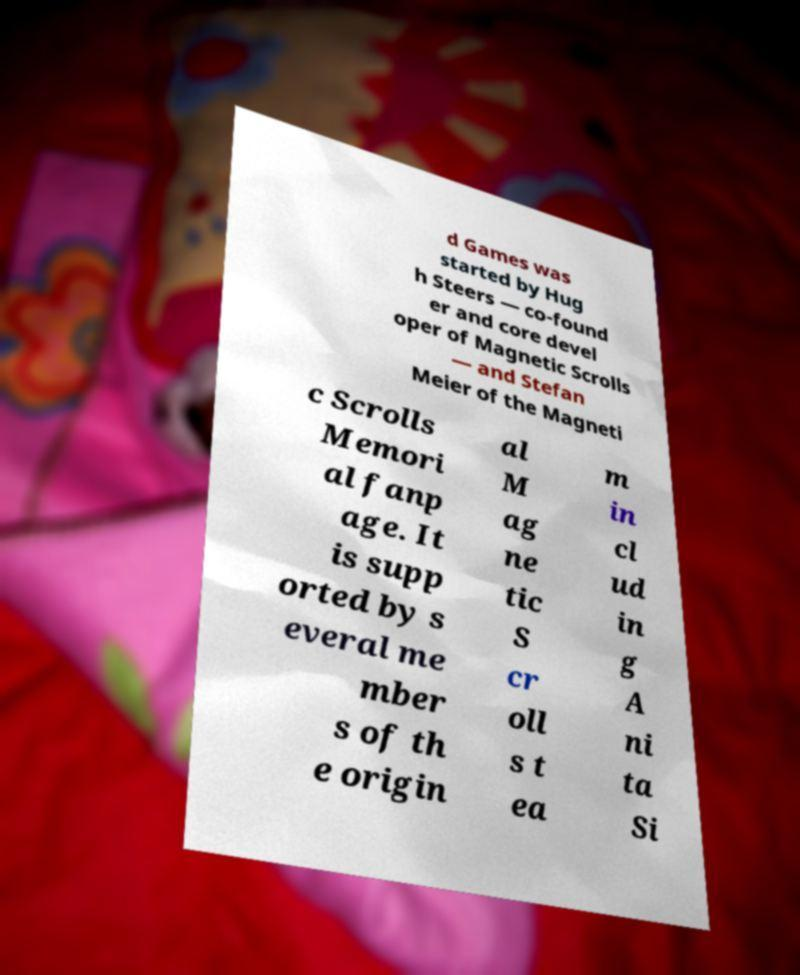For documentation purposes, I need the text within this image transcribed. Could you provide that? d Games was started by Hug h Steers — co-found er and core devel oper of Magnetic Scrolls — and Stefan Meier of the Magneti c Scrolls Memori al fanp age. It is supp orted by s everal me mber s of th e origin al M ag ne tic S cr oll s t ea m in cl ud in g A ni ta Si 